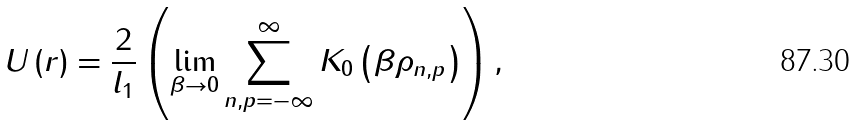Convert formula to latex. <formula><loc_0><loc_0><loc_500><loc_500>U \left ( r \right ) = \frac { 2 } { l _ { 1 } } \left ( \lim _ { \beta \rightarrow 0 } \sum _ { n , p = - \infty } ^ { \infty } K _ { 0 } \left ( \beta \rho _ { n , p } \right ) \right ) ,</formula> 